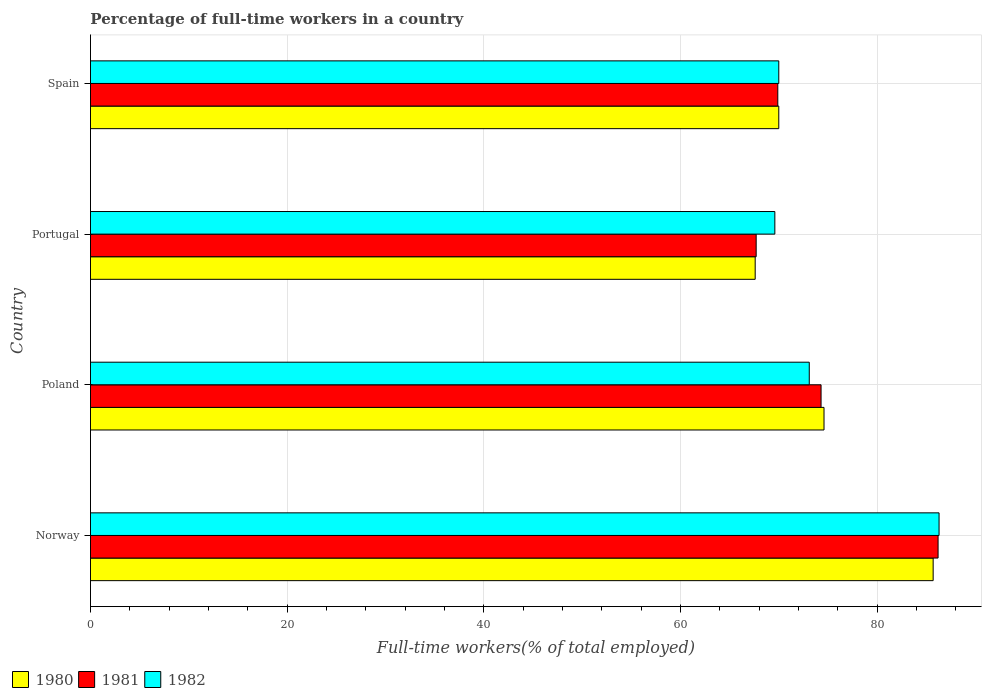How many different coloured bars are there?
Offer a terse response. 3. How many groups of bars are there?
Your answer should be compact. 4. Are the number of bars per tick equal to the number of legend labels?
Make the answer very short. Yes. Are the number of bars on each tick of the Y-axis equal?
Give a very brief answer. Yes. How many bars are there on the 1st tick from the bottom?
Keep it short and to the point. 3. What is the label of the 3rd group of bars from the top?
Provide a succinct answer. Poland. What is the percentage of full-time workers in 1980 in Portugal?
Keep it short and to the point. 67.6. Across all countries, what is the maximum percentage of full-time workers in 1981?
Your answer should be compact. 86.2. Across all countries, what is the minimum percentage of full-time workers in 1980?
Give a very brief answer. 67.6. In which country was the percentage of full-time workers in 1981 maximum?
Your response must be concise. Norway. In which country was the percentage of full-time workers in 1982 minimum?
Offer a very short reply. Portugal. What is the total percentage of full-time workers in 1982 in the graph?
Make the answer very short. 299. What is the difference between the percentage of full-time workers in 1982 in Norway and that in Poland?
Your response must be concise. 13.2. What is the difference between the percentage of full-time workers in 1982 in Spain and the percentage of full-time workers in 1981 in Norway?
Provide a succinct answer. -16.2. What is the average percentage of full-time workers in 1981 per country?
Your answer should be very brief. 74.52. What is the difference between the percentage of full-time workers in 1980 and percentage of full-time workers in 1981 in Poland?
Offer a very short reply. 0.3. In how many countries, is the percentage of full-time workers in 1982 greater than 32 %?
Ensure brevity in your answer.  4. What is the ratio of the percentage of full-time workers in 1982 in Norway to that in Spain?
Offer a very short reply. 1.23. Is the percentage of full-time workers in 1981 in Portugal less than that in Spain?
Give a very brief answer. Yes. What is the difference between the highest and the second highest percentage of full-time workers in 1980?
Give a very brief answer. 11.1. What is the difference between the highest and the lowest percentage of full-time workers in 1980?
Provide a short and direct response. 18.1. In how many countries, is the percentage of full-time workers in 1980 greater than the average percentage of full-time workers in 1980 taken over all countries?
Make the answer very short. 2. What does the 1st bar from the bottom in Poland represents?
Provide a succinct answer. 1980. Is it the case that in every country, the sum of the percentage of full-time workers in 1980 and percentage of full-time workers in 1981 is greater than the percentage of full-time workers in 1982?
Ensure brevity in your answer.  Yes. How many bars are there?
Provide a short and direct response. 12. Are all the bars in the graph horizontal?
Your answer should be very brief. Yes. How many legend labels are there?
Provide a succinct answer. 3. What is the title of the graph?
Ensure brevity in your answer.  Percentage of full-time workers in a country. What is the label or title of the X-axis?
Provide a short and direct response. Full-time workers(% of total employed). What is the Full-time workers(% of total employed) of 1980 in Norway?
Your answer should be compact. 85.7. What is the Full-time workers(% of total employed) of 1981 in Norway?
Your answer should be very brief. 86.2. What is the Full-time workers(% of total employed) in 1982 in Norway?
Offer a terse response. 86.3. What is the Full-time workers(% of total employed) of 1980 in Poland?
Your answer should be very brief. 74.6. What is the Full-time workers(% of total employed) in 1981 in Poland?
Your answer should be very brief. 74.3. What is the Full-time workers(% of total employed) of 1982 in Poland?
Provide a short and direct response. 73.1. What is the Full-time workers(% of total employed) in 1980 in Portugal?
Make the answer very short. 67.6. What is the Full-time workers(% of total employed) of 1981 in Portugal?
Make the answer very short. 67.7. What is the Full-time workers(% of total employed) in 1982 in Portugal?
Your answer should be compact. 69.6. What is the Full-time workers(% of total employed) in 1980 in Spain?
Make the answer very short. 70. What is the Full-time workers(% of total employed) of 1981 in Spain?
Provide a short and direct response. 69.9. Across all countries, what is the maximum Full-time workers(% of total employed) of 1980?
Give a very brief answer. 85.7. Across all countries, what is the maximum Full-time workers(% of total employed) in 1981?
Offer a very short reply. 86.2. Across all countries, what is the maximum Full-time workers(% of total employed) of 1982?
Provide a succinct answer. 86.3. Across all countries, what is the minimum Full-time workers(% of total employed) of 1980?
Make the answer very short. 67.6. Across all countries, what is the minimum Full-time workers(% of total employed) in 1981?
Your answer should be compact. 67.7. Across all countries, what is the minimum Full-time workers(% of total employed) of 1982?
Your response must be concise. 69.6. What is the total Full-time workers(% of total employed) in 1980 in the graph?
Your answer should be very brief. 297.9. What is the total Full-time workers(% of total employed) in 1981 in the graph?
Offer a very short reply. 298.1. What is the total Full-time workers(% of total employed) in 1982 in the graph?
Ensure brevity in your answer.  299. What is the difference between the Full-time workers(% of total employed) in 1980 in Norway and that in Poland?
Your answer should be compact. 11.1. What is the difference between the Full-time workers(% of total employed) in 1981 in Norway and that in Poland?
Provide a short and direct response. 11.9. What is the difference between the Full-time workers(% of total employed) of 1980 in Norway and that in Spain?
Offer a terse response. 15.7. What is the difference between the Full-time workers(% of total employed) in 1982 in Norway and that in Spain?
Make the answer very short. 16.3. What is the difference between the Full-time workers(% of total employed) of 1980 in Poland and that in Portugal?
Make the answer very short. 7. What is the difference between the Full-time workers(% of total employed) in 1981 in Poland and that in Portugal?
Give a very brief answer. 6.6. What is the difference between the Full-time workers(% of total employed) of 1982 in Poland and that in Spain?
Give a very brief answer. 3.1. What is the difference between the Full-time workers(% of total employed) of 1981 in Portugal and that in Spain?
Ensure brevity in your answer.  -2.2. What is the difference between the Full-time workers(% of total employed) of 1980 in Norway and the Full-time workers(% of total employed) of 1981 in Poland?
Your answer should be compact. 11.4. What is the difference between the Full-time workers(% of total employed) in 1980 in Norway and the Full-time workers(% of total employed) in 1982 in Spain?
Your answer should be very brief. 15.7. What is the difference between the Full-time workers(% of total employed) in 1980 in Poland and the Full-time workers(% of total employed) in 1981 in Spain?
Give a very brief answer. 4.7. What is the difference between the Full-time workers(% of total employed) in 1981 in Poland and the Full-time workers(% of total employed) in 1982 in Spain?
Give a very brief answer. 4.3. What is the difference between the Full-time workers(% of total employed) of 1981 in Portugal and the Full-time workers(% of total employed) of 1982 in Spain?
Provide a short and direct response. -2.3. What is the average Full-time workers(% of total employed) of 1980 per country?
Provide a succinct answer. 74.47. What is the average Full-time workers(% of total employed) in 1981 per country?
Give a very brief answer. 74.53. What is the average Full-time workers(% of total employed) of 1982 per country?
Offer a terse response. 74.75. What is the difference between the Full-time workers(% of total employed) in 1981 and Full-time workers(% of total employed) in 1982 in Norway?
Your response must be concise. -0.1. What is the difference between the Full-time workers(% of total employed) of 1981 and Full-time workers(% of total employed) of 1982 in Portugal?
Your answer should be very brief. -1.9. What is the ratio of the Full-time workers(% of total employed) of 1980 in Norway to that in Poland?
Your answer should be compact. 1.15. What is the ratio of the Full-time workers(% of total employed) of 1981 in Norway to that in Poland?
Provide a short and direct response. 1.16. What is the ratio of the Full-time workers(% of total employed) in 1982 in Norway to that in Poland?
Make the answer very short. 1.18. What is the ratio of the Full-time workers(% of total employed) of 1980 in Norway to that in Portugal?
Provide a short and direct response. 1.27. What is the ratio of the Full-time workers(% of total employed) of 1981 in Norway to that in Portugal?
Provide a succinct answer. 1.27. What is the ratio of the Full-time workers(% of total employed) of 1982 in Norway to that in Portugal?
Give a very brief answer. 1.24. What is the ratio of the Full-time workers(% of total employed) in 1980 in Norway to that in Spain?
Ensure brevity in your answer.  1.22. What is the ratio of the Full-time workers(% of total employed) in 1981 in Norway to that in Spain?
Offer a very short reply. 1.23. What is the ratio of the Full-time workers(% of total employed) of 1982 in Norway to that in Spain?
Give a very brief answer. 1.23. What is the ratio of the Full-time workers(% of total employed) of 1980 in Poland to that in Portugal?
Your answer should be compact. 1.1. What is the ratio of the Full-time workers(% of total employed) in 1981 in Poland to that in Portugal?
Make the answer very short. 1.1. What is the ratio of the Full-time workers(% of total employed) of 1982 in Poland to that in Portugal?
Make the answer very short. 1.05. What is the ratio of the Full-time workers(% of total employed) in 1980 in Poland to that in Spain?
Make the answer very short. 1.07. What is the ratio of the Full-time workers(% of total employed) in 1981 in Poland to that in Spain?
Your response must be concise. 1.06. What is the ratio of the Full-time workers(% of total employed) of 1982 in Poland to that in Spain?
Provide a short and direct response. 1.04. What is the ratio of the Full-time workers(% of total employed) in 1980 in Portugal to that in Spain?
Your response must be concise. 0.97. What is the ratio of the Full-time workers(% of total employed) of 1981 in Portugal to that in Spain?
Give a very brief answer. 0.97. What is the ratio of the Full-time workers(% of total employed) in 1982 in Portugal to that in Spain?
Provide a short and direct response. 0.99. What is the difference between the highest and the second highest Full-time workers(% of total employed) of 1980?
Offer a terse response. 11.1. 